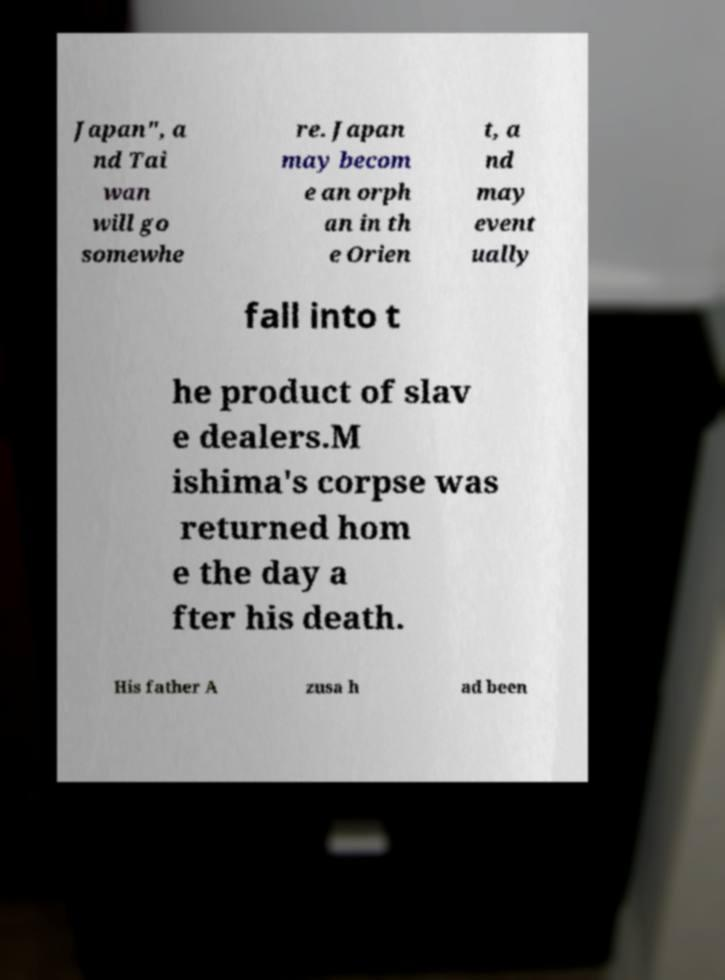Could you extract and type out the text from this image? Japan", a nd Tai wan will go somewhe re. Japan may becom e an orph an in th e Orien t, a nd may event ually fall into t he product of slav e dealers.M ishima's corpse was returned hom e the day a fter his death. His father A zusa h ad been 